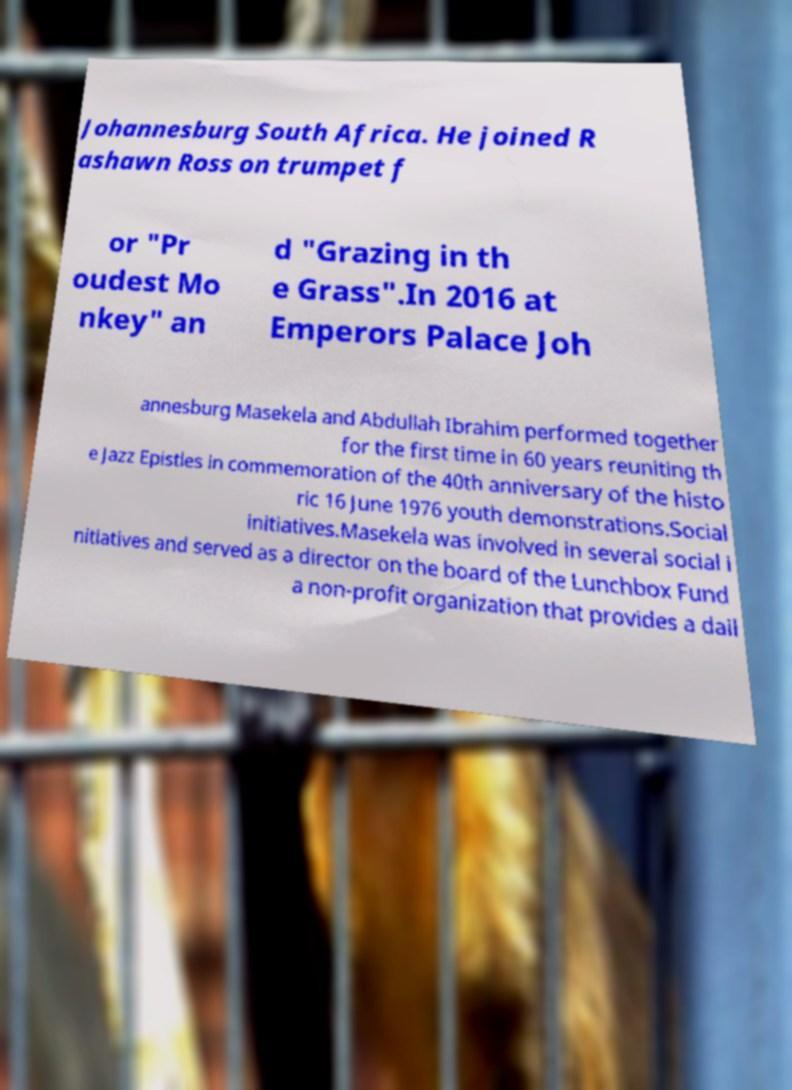Could you assist in decoding the text presented in this image and type it out clearly? Johannesburg South Africa. He joined R ashawn Ross on trumpet f or "Pr oudest Mo nkey" an d "Grazing in th e Grass".In 2016 at Emperors Palace Joh annesburg Masekela and Abdullah Ibrahim performed together for the first time in 60 years reuniting th e Jazz Epistles in commemoration of the 40th anniversary of the histo ric 16 June 1976 youth demonstrations.Social initiatives.Masekela was involved in several social i nitiatives and served as a director on the board of the Lunchbox Fund a non-profit organization that provides a dail 